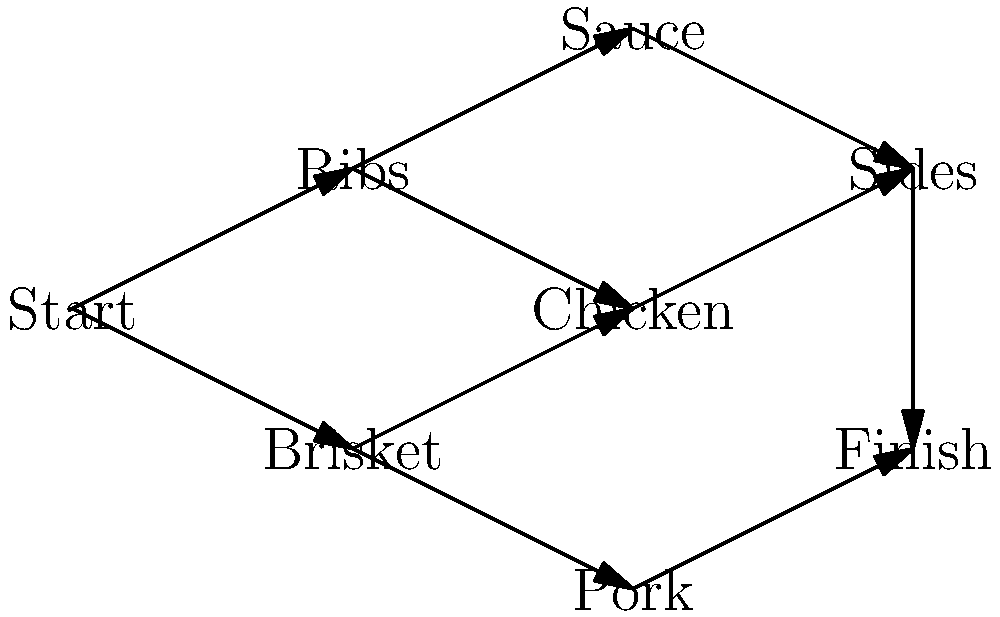As a competitive barbecuer, you need to optimize your cooking schedule. The directed acyclic graph above represents the dependencies and cooking order for different meats and sides. Each node represents a task, and each edge represents a dependency. If cooking ribs takes 4 hours, brisket takes 12 hours, sauce takes 1 hour, chicken takes 2 hours, pork takes 8 hours, and sides take 1 hour, what is the minimum total time required to complete all tasks, assuming you can work on multiple tasks simultaneously when there are no dependencies? To find the minimum total time, we need to identify the critical path in the directed acyclic graph. The critical path is the longest path from start to finish, considering the cooking times for each item. Let's analyze the possible paths:

1. Start → Ribs → Sauce → Sides → Finish
   Time: 4 + 1 + 1 = 6 hours

2. Start → Ribs → Chicken → Sides → Finish
   Time: 4 + 2 + 1 = 7 hours

3. Start → Brisket → Chicken → Sides → Finish
   Time: 12 + 2 + 1 = 15 hours

4. Start → Brisket → Pork → Finish
   Time: 12 + 8 = 20 hours

The critical path is the one with the longest total time, which is path 4: Start → Brisket → Pork → Finish, taking 20 hours.

Note that while the brisket is cooking, we can simultaneously work on ribs, sauce, chicken, and sides, as they have no dependencies on the brisket. However, this doesn't affect the total time because the critical path (brisket and pork) takes longer than all other tasks combined.

Therefore, the minimum total time required to complete all tasks is 20 hours.
Answer: 20 hours 